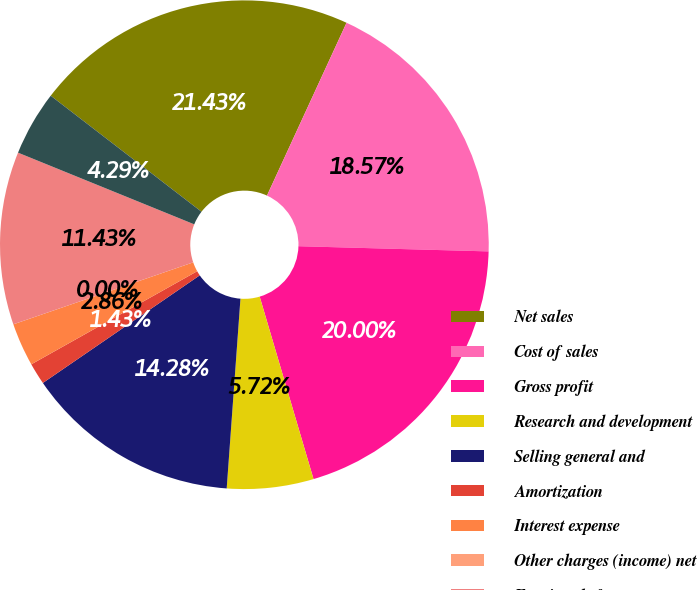Convert chart. <chart><loc_0><loc_0><loc_500><loc_500><pie_chart><fcel>Net sales<fcel>Cost of sales<fcel>Gross profit<fcel>Research and development<fcel>Selling general and<fcel>Amortization<fcel>Interest expense<fcel>Other charges (income) net<fcel>Earnings before taxes<fcel>Provision for taxes ^(c)<nl><fcel>21.43%<fcel>18.57%<fcel>20.0%<fcel>5.72%<fcel>14.28%<fcel>1.43%<fcel>2.86%<fcel>0.0%<fcel>11.43%<fcel>4.29%<nl></chart> 